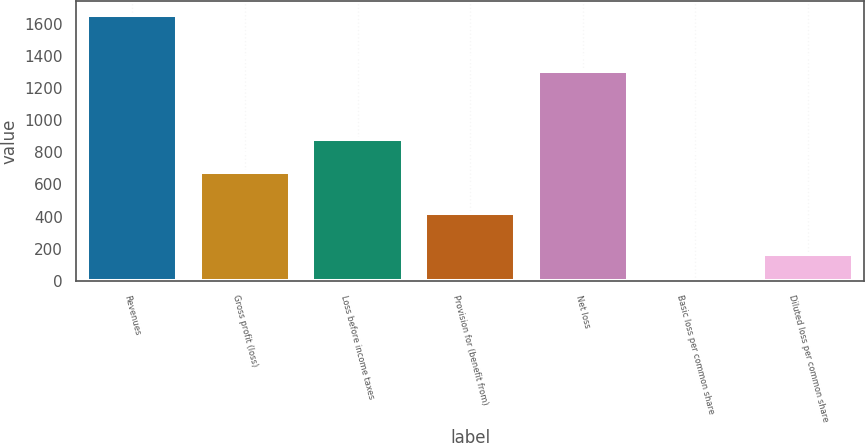Convert chart to OTSL. <chart><loc_0><loc_0><loc_500><loc_500><bar_chart><fcel>Revenues<fcel>Gross profit (loss)<fcel>Loss before income taxes<fcel>Provision for (benefit from)<fcel>Net loss<fcel>Basic loss per common share<fcel>Diluted loss per common share<nl><fcel>1656.9<fcel>678.8<fcel>884.6<fcel>421<fcel>1305.6<fcel>4.14<fcel>169.42<nl></chart> 